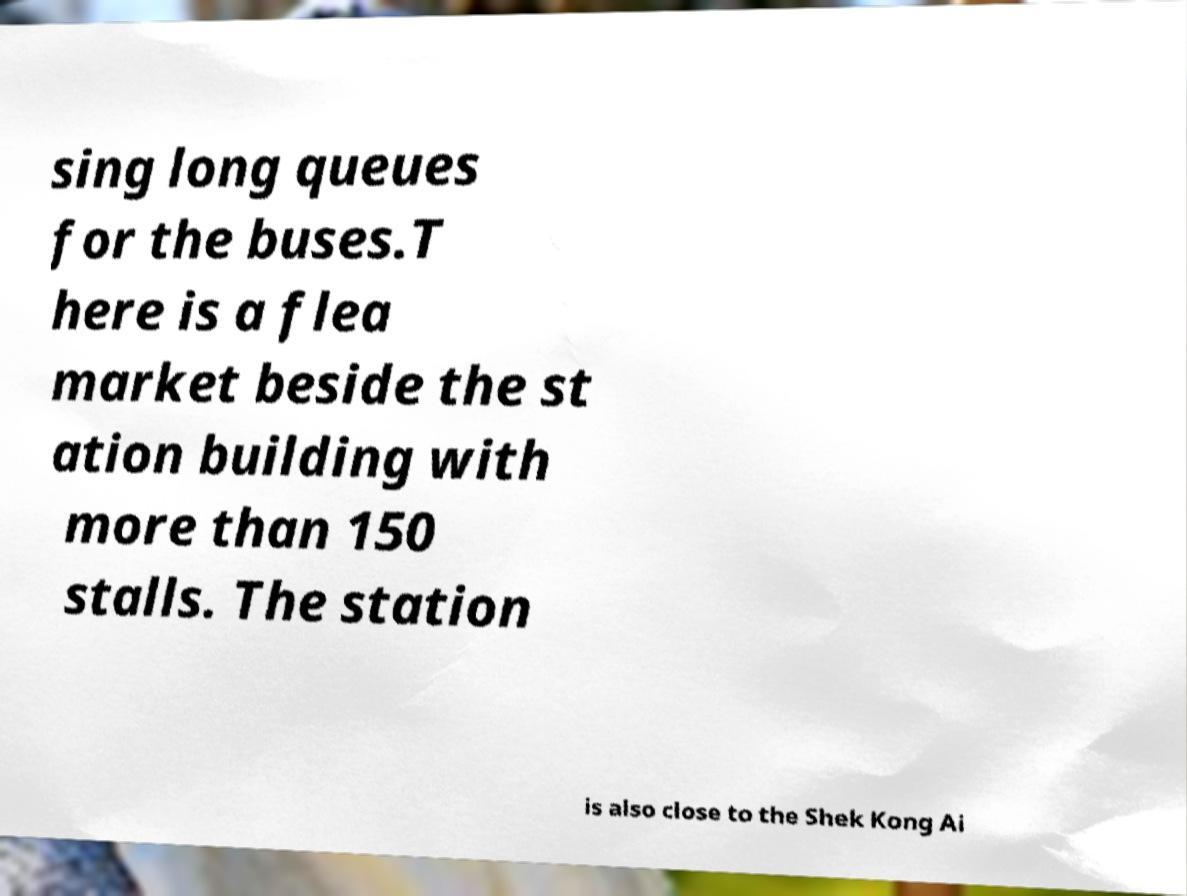What messages or text are displayed in this image? I need them in a readable, typed format. sing long queues for the buses.T here is a flea market beside the st ation building with more than 150 stalls. The station is also close to the Shek Kong Ai 